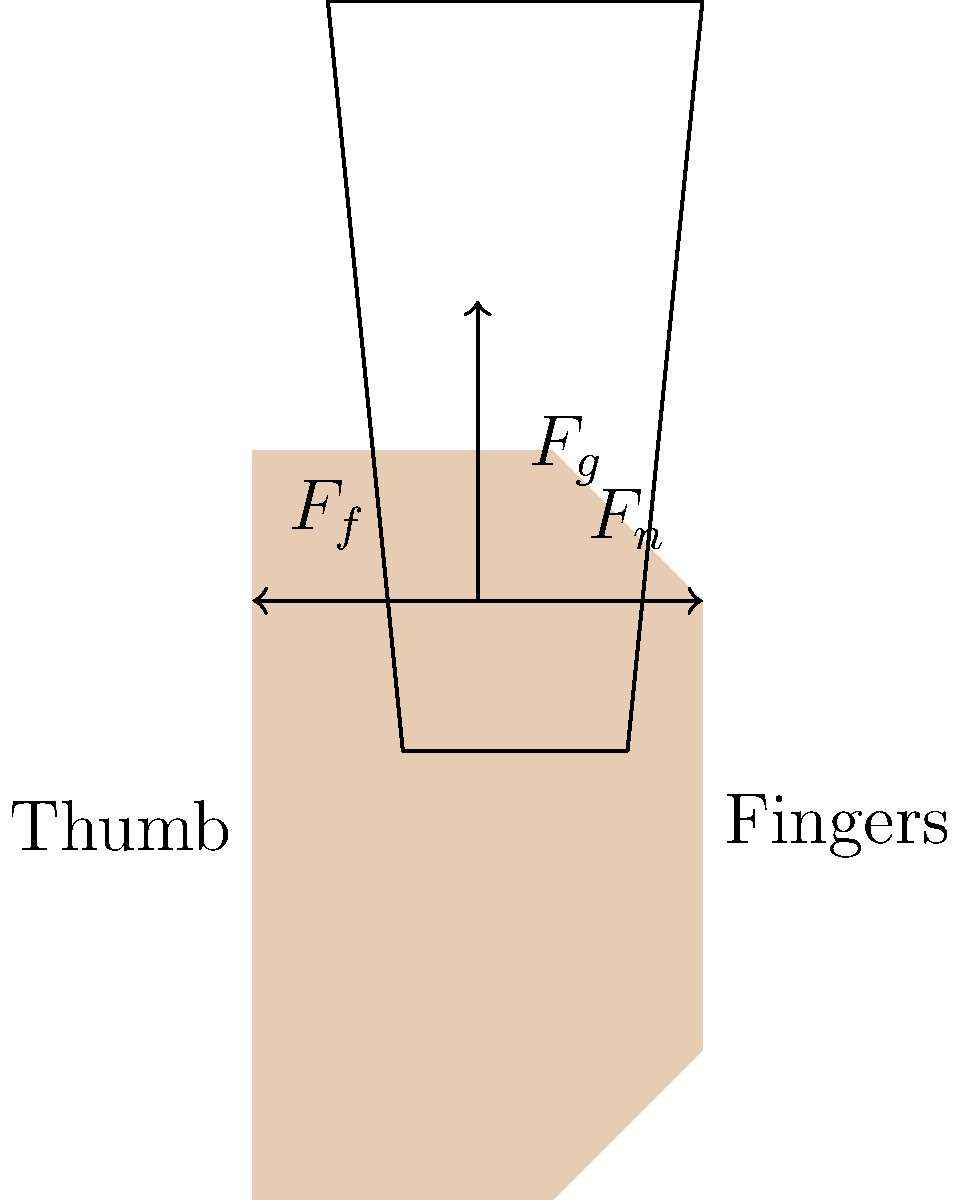As you hold your favorite pint glass during St. Patrick's Day celebrations, consider the forces acting on your hand. What are the primary forces involved in maintaining a stable grip on the glass, and how do they relate to each other? To understand the forces involved in holding a pint glass, let's break it down step-by-step:

1. Gravitational Force ($F_g$):
   - This is the downward force exerted by the weight of the glass and its contents.
   - $F_g = mg$, where $m$ is the mass of the glass and its contents, and $g$ is the acceleration due to gravity.

2. Normal Force ($F_n$):
   - This is the force exerted by your fingers perpendicular to the surface of the glass.
   - It counteracts the tendency of the glass to slip through your fingers.

3. Friction Force ($F_f$):
   - This is the force that prevents the glass from slipping down your hand.
   - $F_f = \mu F_n$, where $\mu$ is the coefficient of friction between your skin and the glass.

4. Force Balance:
   - For the glass to remain stationary in your hand, the upward forces must balance the downward force.
   - Vertically: $F_f = F_g$
   - Horizontally: The normal forces from your thumb and fingers must be equal and opposite.

5. Grip Stability:
   - The friction force must be greater than or equal to the weight of the glass: $F_f \geq F_g$
   - This condition is met when: $\mu F_n \geq mg$

6. Minimum Required Normal Force:
   - Rearranging the above inequality: $F_n \geq \frac{mg}{\mu}$
   - This is the minimum normal force needed to prevent the glass from slipping.

In summary, a stable grip is maintained when the friction force (determined by the normal force and coefficient of friction) is sufficient to counteract the gravitational force, while the normal forces from the thumb and fingers provide the necessary pressure to create this friction.
Answer: Balance of gravitational force ($F_g$), normal force ($F_n$), and friction force ($F_f$), where $F_f \geq F_g$ and $F_n \geq \frac{mg}{\mu}$. 